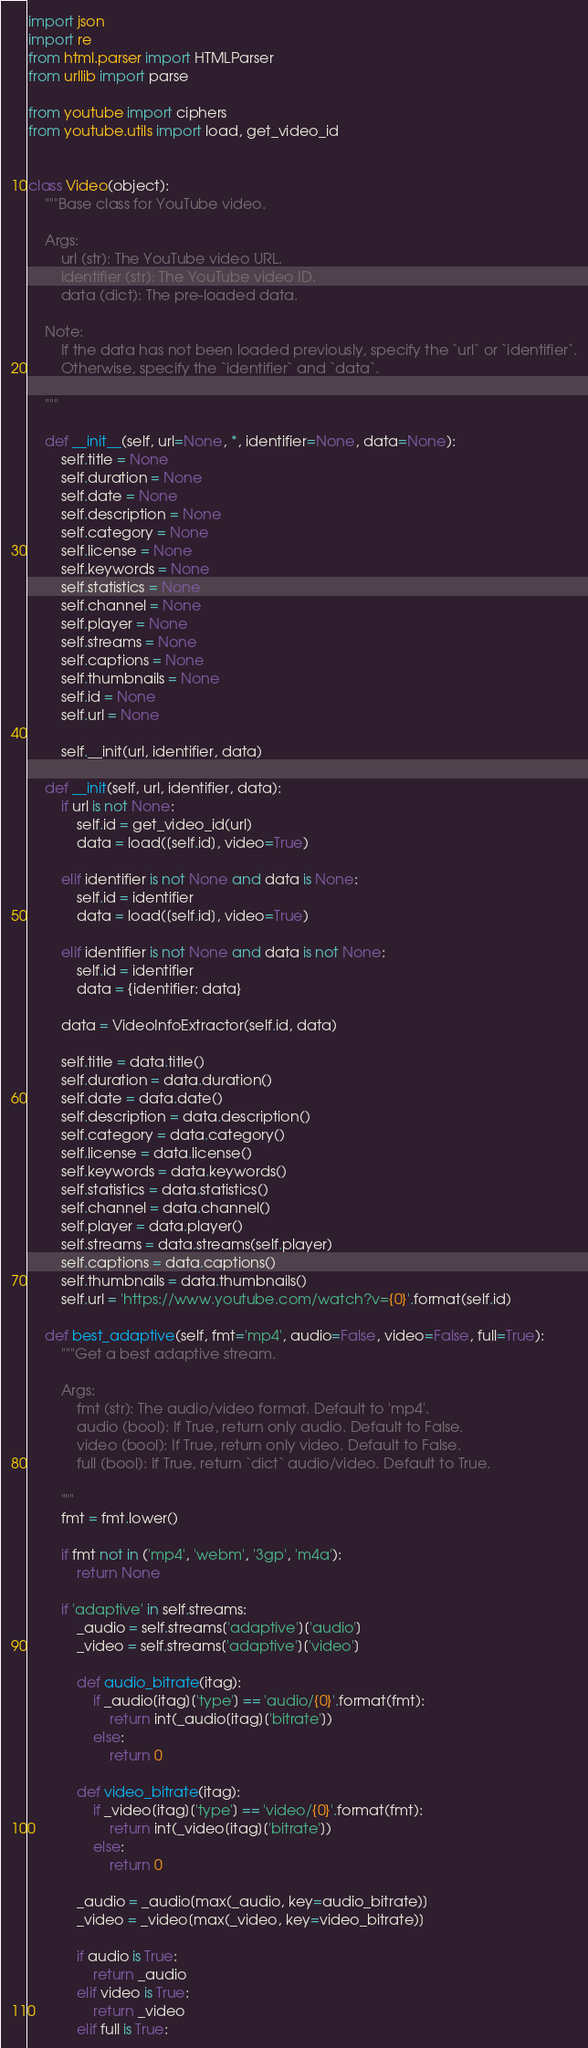Convert code to text. <code><loc_0><loc_0><loc_500><loc_500><_Python_>import json
import re
from html.parser import HTMLParser
from urllib import parse

from youtube import ciphers
from youtube.utils import load, get_video_id


class Video(object):
    """Base class for YouTube video.

    Args:
        url (str): The YouTube video URL.
        identifier (str): The YouTube video ID.
        data (dict): The pre-loaded data.

    Note:
        If the data has not been loaded previously, specify the `url` or `identifier`.
        Otherwise, specify the `identifier` and `data`.

    """

    def __init__(self, url=None, *, identifier=None, data=None):
        self.title = None
        self.duration = None
        self.date = None
        self.description = None
        self.category = None
        self.license = None
        self.keywords = None
        self.statistics = None
        self.channel = None
        self.player = None
        self.streams = None
        self.captions = None
        self.thumbnails = None
        self.id = None
        self.url = None

        self.__init(url, identifier, data)

    def __init(self, url, identifier, data):
        if url is not None:
            self.id = get_video_id(url)
            data = load([self.id], video=True)

        elif identifier is not None and data is None:
            self.id = identifier
            data = load([self.id], video=True)

        elif identifier is not None and data is not None:
            self.id = identifier
            data = {identifier: data}

        data = VideoInfoExtractor(self.id, data)

        self.title = data.title()
        self.duration = data.duration()
        self.date = data.date()
        self.description = data.description()
        self.category = data.category()
        self.license = data.license()
        self.keywords = data.keywords()
        self.statistics = data.statistics()
        self.channel = data.channel()
        self.player = data.player()
        self.streams = data.streams(self.player)
        self.captions = data.captions()
        self.thumbnails = data.thumbnails()
        self.url = 'https://www.youtube.com/watch?v={0}'.format(self.id)

    def best_adaptive(self, fmt='mp4', audio=False, video=False, full=True):
        """Get a best adaptive stream.

        Args:
            fmt (str): The audio/video format. Default to 'mp4'.
            audio (bool): If True, return only audio. Default to False.
            video (bool): If True, return only video. Default to False.
            full (bool): If True, return `dict` audio/video. Default to True.

        """
        fmt = fmt.lower()

        if fmt not in ('mp4', 'webm', '3gp', 'm4a'):
            return None

        if 'adaptive' in self.streams:
            _audio = self.streams['adaptive']['audio']
            _video = self.streams['adaptive']['video']

            def audio_bitrate(itag):
                if _audio[itag]['type'] == 'audio/{0}'.format(fmt):
                    return int(_audio[itag]['bitrate'])
                else:
                    return 0

            def video_bitrate(itag):
                if _video[itag]['type'] == 'video/{0}'.format(fmt):
                    return int(_video[itag]['bitrate'])
                else:
                    return 0

            _audio = _audio[max(_audio, key=audio_bitrate)]
            _video = _video[max(_video, key=video_bitrate)]

            if audio is True:
                return _audio
            elif video is True:
                return _video
            elif full is True:</code> 